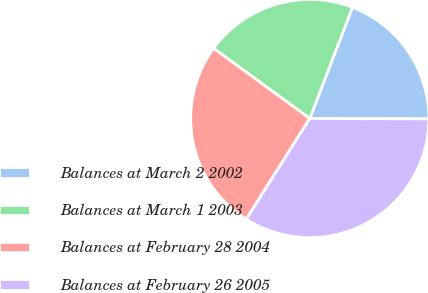Convert chart. <chart><loc_0><loc_0><loc_500><loc_500><pie_chart><fcel>Balances at March 2 2002<fcel>Balances at March 1 2003<fcel>Balances at February 28 2004<fcel>Balances at February 26 2005<nl><fcel>19.21%<fcel>20.8%<fcel>26.08%<fcel>33.9%<nl></chart> 